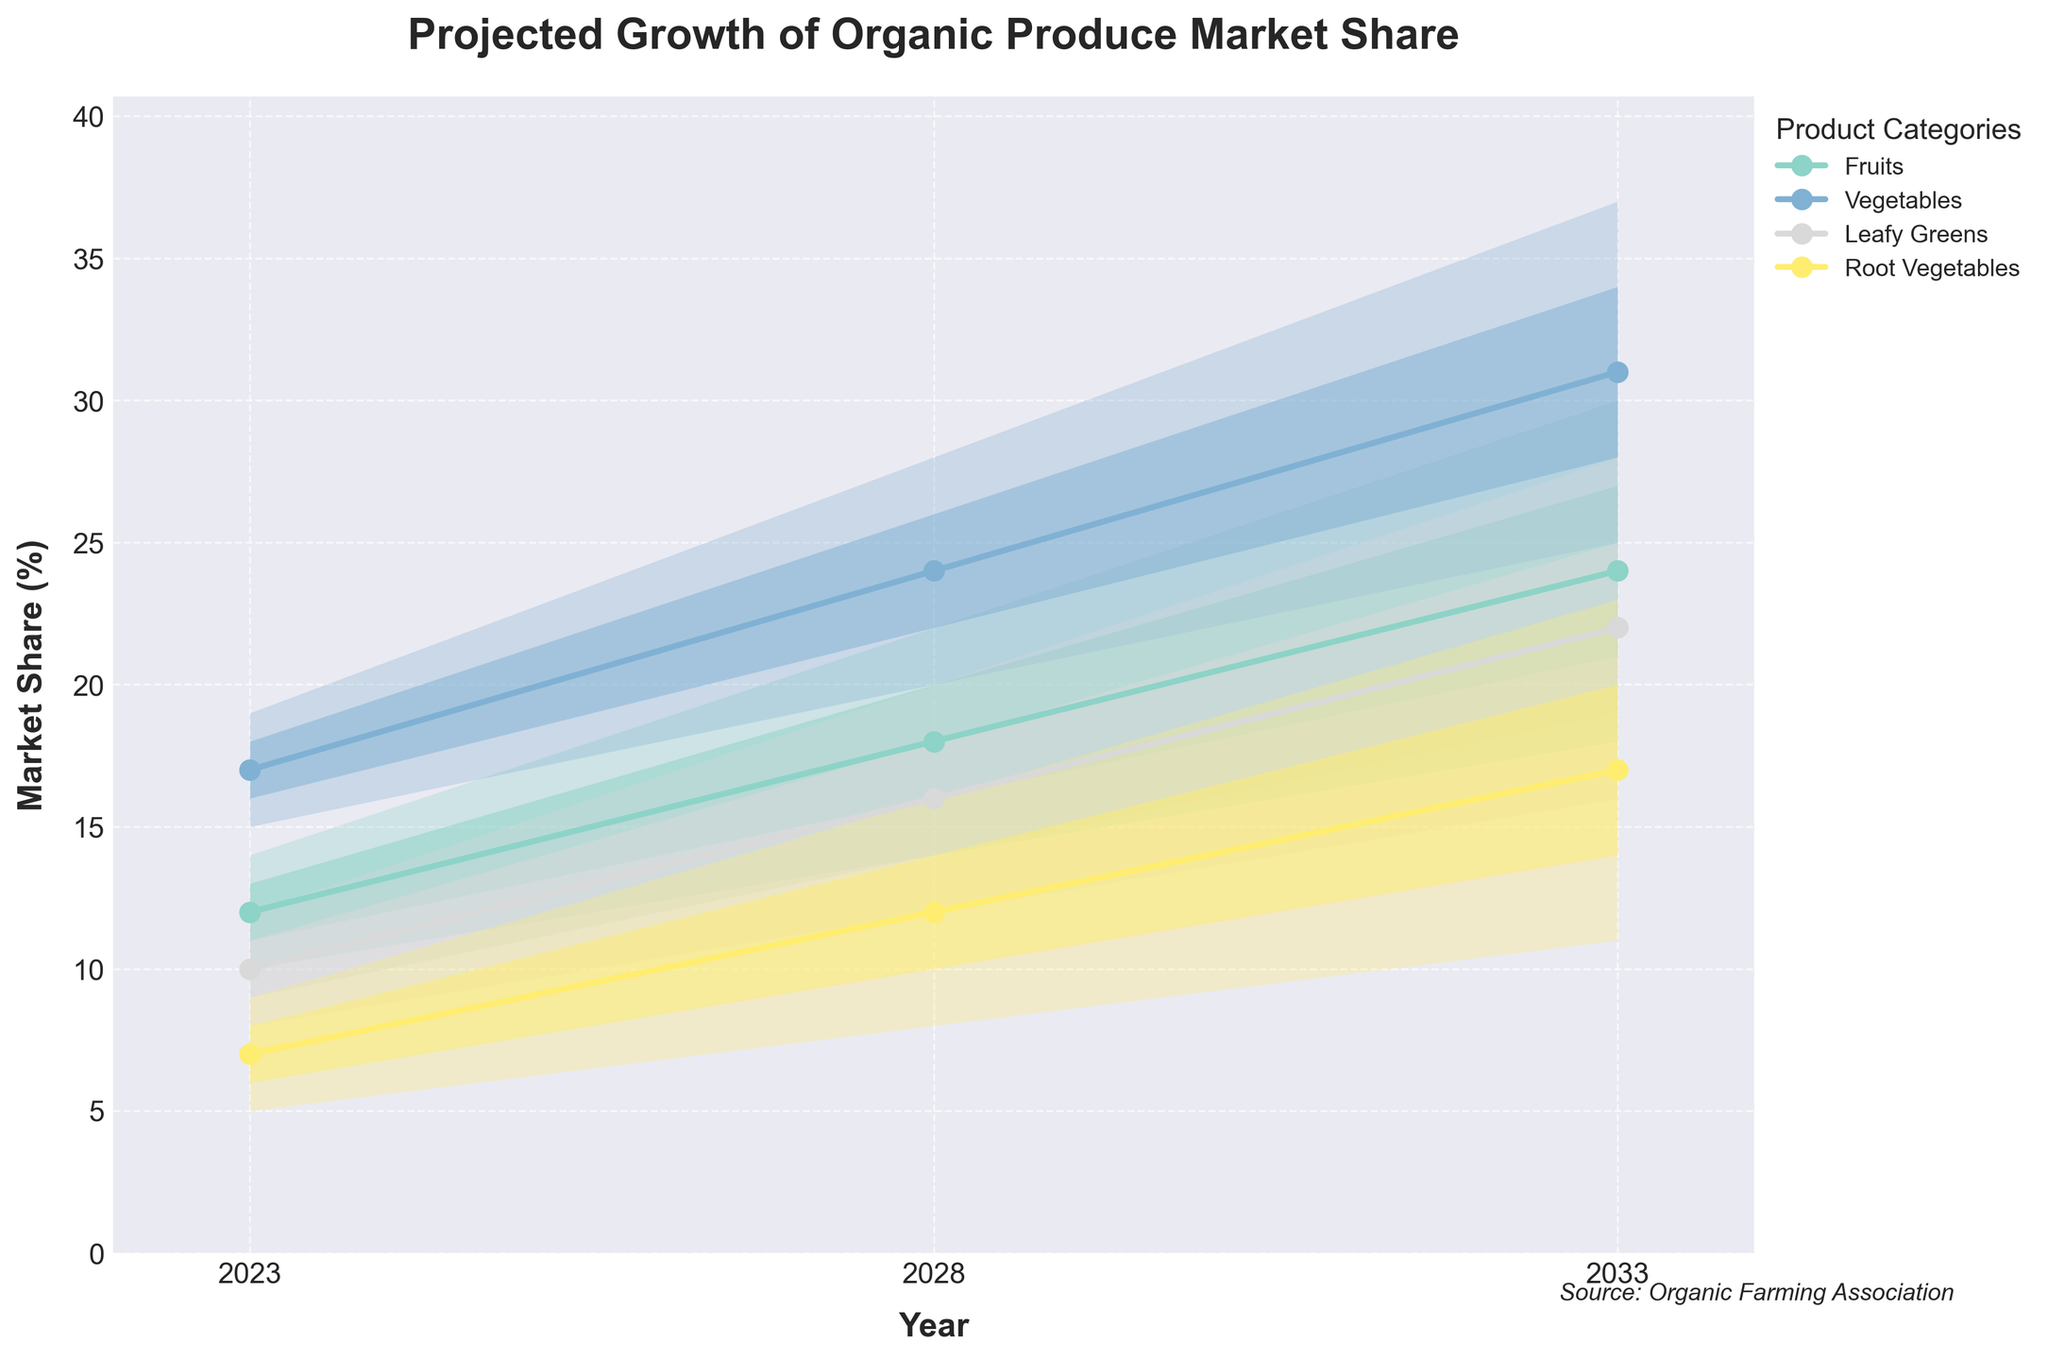What is the title of the figure? The title is found at the top of the chart, it is bold and informative about the content.
Answer: Projected Growth of Organic Produce Market Share What products have the highest projected market share in 2033 in the median scenario? Look at the Year 2033 and compare the 'Mid' values for each product category.
Answer: Vegetables How does the market share projection for Fruits change from 2023 to 2033 in the high scenario? Find the 'High' values for Fruits in 2023 and 2033, and then calculate the difference.
Answer: 16 Which product category shows the smallest projected growth in the median scenario from 2023 to 2028? Calculate the difference in 'Mid' values for each category between 2023 and 2028, and identify the smallest increase.
Answer: Root Vegetables By how many percentage points is the projected market share of Leafy Greens higher than Root Vegetables in 2028 in the low scenario? Find the 'Low' value for Leafy Greens and Root Vegetables in 2028 and calculate the difference.
Answer: 4 What is the range of projected market share for Vegetables in 2033? Look at the 'Low' and 'High' values for Vegetables in 2033 and subtract the 'Low' from the 'High'.
Answer: 12 What trend can be observed in the market share of Fruits over the next decade in the median scenario? Observe the 'Mid' values for Fruits from 2023 to 2033 and describe the trend.
Answer: Increasing Which product category has the most stable projections (smallest range between low and high) in 2023? For 2023, calculate the range (High - Low) for each product category and identify the smallest value.
Answer: Root Vegetables What is the average projected market share for all products combined in 2028 in the low-mid scenario? Sum the 'LowMid' values for all product categories in 2028 and divide by the number of categories.
Answer: 15.5 